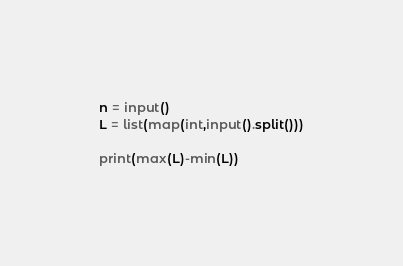<code> <loc_0><loc_0><loc_500><loc_500><_Python_>n = input()
L = list(map(int,input().split()))

print(max(L)-min(L))</code> 